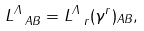<formula> <loc_0><loc_0><loc_500><loc_500>L ^ { \Lambda } _ { \ A B } = L ^ { \Lambda } _ { \ r } ( \gamma ^ { r } ) _ { A B } ,</formula> 